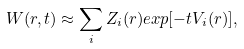<formula> <loc_0><loc_0><loc_500><loc_500>W ( { r } , t ) \approx \sum _ { i } Z _ { i } ( { r } ) e x p [ - t V _ { i } ( { r } ) ] ,</formula> 